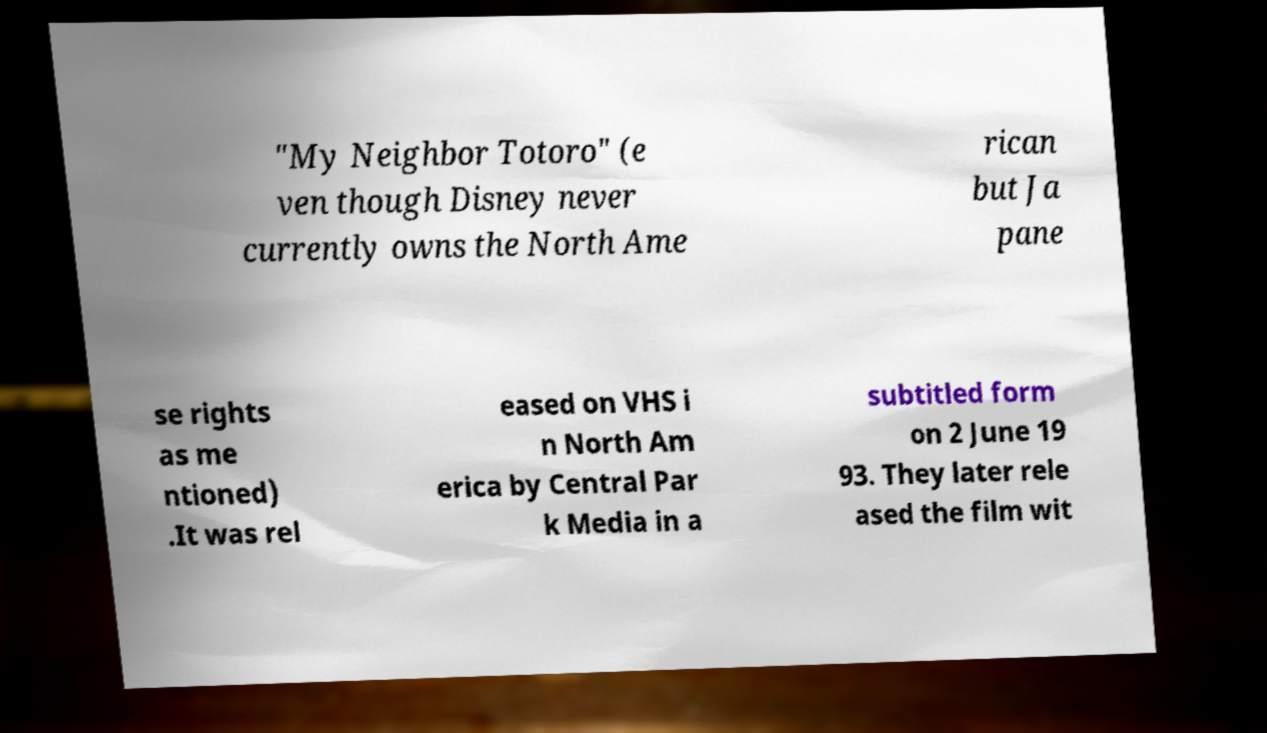Could you extract and type out the text from this image? "My Neighbor Totoro" (e ven though Disney never currently owns the North Ame rican but Ja pane se rights as me ntioned) .It was rel eased on VHS i n North Am erica by Central Par k Media in a subtitled form on 2 June 19 93. They later rele ased the film wit 